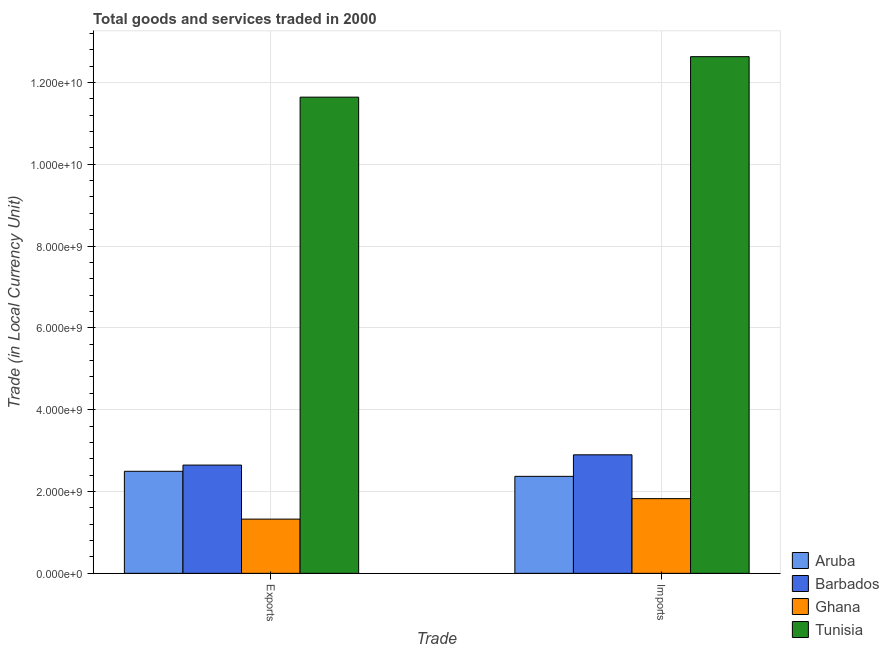How many different coloured bars are there?
Provide a succinct answer. 4. How many groups of bars are there?
Give a very brief answer. 2. Are the number of bars on each tick of the X-axis equal?
Offer a terse response. Yes. How many bars are there on the 2nd tick from the left?
Offer a very short reply. 4. How many bars are there on the 1st tick from the right?
Make the answer very short. 4. What is the label of the 1st group of bars from the left?
Your response must be concise. Exports. What is the imports of goods and services in Tunisia?
Give a very brief answer. 1.26e+1. Across all countries, what is the maximum export of goods and services?
Offer a very short reply. 1.16e+1. Across all countries, what is the minimum imports of goods and services?
Ensure brevity in your answer.  1.83e+09. In which country was the export of goods and services maximum?
Provide a short and direct response. Tunisia. In which country was the imports of goods and services minimum?
Ensure brevity in your answer.  Ghana. What is the total export of goods and services in the graph?
Your answer should be compact. 1.81e+1. What is the difference between the export of goods and services in Tunisia and that in Ghana?
Your answer should be very brief. 1.03e+1. What is the difference between the imports of goods and services in Ghana and the export of goods and services in Barbados?
Ensure brevity in your answer.  -8.20e+08. What is the average imports of goods and services per country?
Give a very brief answer. 4.93e+09. What is the difference between the export of goods and services and imports of goods and services in Ghana?
Your response must be concise. -5.01e+08. In how many countries, is the imports of goods and services greater than 12800000000 LCU?
Your response must be concise. 0. What is the ratio of the export of goods and services in Ghana to that in Tunisia?
Give a very brief answer. 0.11. What does the 3rd bar from the left in Exports represents?
Your response must be concise. Ghana. What does the 3rd bar from the right in Exports represents?
Keep it short and to the point. Barbados. What is the difference between two consecutive major ticks on the Y-axis?
Keep it short and to the point. 2.00e+09. Are the values on the major ticks of Y-axis written in scientific E-notation?
Your answer should be very brief. Yes. Does the graph contain grids?
Make the answer very short. Yes. How are the legend labels stacked?
Ensure brevity in your answer.  Vertical. What is the title of the graph?
Offer a very short reply. Total goods and services traded in 2000. Does "Belgium" appear as one of the legend labels in the graph?
Offer a terse response. No. What is the label or title of the X-axis?
Offer a very short reply. Trade. What is the label or title of the Y-axis?
Make the answer very short. Trade (in Local Currency Unit). What is the Trade (in Local Currency Unit) in Aruba in Exports?
Your response must be concise. 2.49e+09. What is the Trade (in Local Currency Unit) of Barbados in Exports?
Your answer should be compact. 2.65e+09. What is the Trade (in Local Currency Unit) of Ghana in Exports?
Your response must be concise. 1.33e+09. What is the Trade (in Local Currency Unit) in Tunisia in Exports?
Provide a short and direct response. 1.16e+1. What is the Trade (in Local Currency Unit) of Aruba in Imports?
Ensure brevity in your answer.  2.37e+09. What is the Trade (in Local Currency Unit) of Barbados in Imports?
Offer a terse response. 2.90e+09. What is the Trade (in Local Currency Unit) of Ghana in Imports?
Provide a succinct answer. 1.83e+09. What is the Trade (in Local Currency Unit) in Tunisia in Imports?
Provide a short and direct response. 1.26e+1. Across all Trade, what is the maximum Trade (in Local Currency Unit) of Aruba?
Provide a short and direct response. 2.49e+09. Across all Trade, what is the maximum Trade (in Local Currency Unit) of Barbados?
Provide a succinct answer. 2.90e+09. Across all Trade, what is the maximum Trade (in Local Currency Unit) in Ghana?
Offer a terse response. 1.83e+09. Across all Trade, what is the maximum Trade (in Local Currency Unit) of Tunisia?
Make the answer very short. 1.26e+1. Across all Trade, what is the minimum Trade (in Local Currency Unit) of Aruba?
Your answer should be compact. 2.37e+09. Across all Trade, what is the minimum Trade (in Local Currency Unit) of Barbados?
Ensure brevity in your answer.  2.65e+09. Across all Trade, what is the minimum Trade (in Local Currency Unit) in Ghana?
Ensure brevity in your answer.  1.33e+09. Across all Trade, what is the minimum Trade (in Local Currency Unit) of Tunisia?
Your response must be concise. 1.16e+1. What is the total Trade (in Local Currency Unit) of Aruba in the graph?
Ensure brevity in your answer.  4.86e+09. What is the total Trade (in Local Currency Unit) of Barbados in the graph?
Your answer should be very brief. 5.54e+09. What is the total Trade (in Local Currency Unit) in Ghana in the graph?
Give a very brief answer. 3.15e+09. What is the total Trade (in Local Currency Unit) of Tunisia in the graph?
Your answer should be very brief. 2.43e+1. What is the difference between the Trade (in Local Currency Unit) of Aruba in Exports and that in Imports?
Your response must be concise. 1.24e+08. What is the difference between the Trade (in Local Currency Unit) in Barbados in Exports and that in Imports?
Keep it short and to the point. -2.51e+08. What is the difference between the Trade (in Local Currency Unit) in Ghana in Exports and that in Imports?
Your answer should be very brief. -5.01e+08. What is the difference between the Trade (in Local Currency Unit) of Tunisia in Exports and that in Imports?
Your answer should be compact. -9.90e+08. What is the difference between the Trade (in Local Currency Unit) in Aruba in Exports and the Trade (in Local Currency Unit) in Barbados in Imports?
Your response must be concise. -4.02e+08. What is the difference between the Trade (in Local Currency Unit) in Aruba in Exports and the Trade (in Local Currency Unit) in Ghana in Imports?
Provide a short and direct response. 6.69e+08. What is the difference between the Trade (in Local Currency Unit) in Aruba in Exports and the Trade (in Local Currency Unit) in Tunisia in Imports?
Offer a terse response. -1.01e+1. What is the difference between the Trade (in Local Currency Unit) in Barbados in Exports and the Trade (in Local Currency Unit) in Ghana in Imports?
Your answer should be compact. 8.20e+08. What is the difference between the Trade (in Local Currency Unit) of Barbados in Exports and the Trade (in Local Currency Unit) of Tunisia in Imports?
Offer a terse response. -9.98e+09. What is the difference between the Trade (in Local Currency Unit) of Ghana in Exports and the Trade (in Local Currency Unit) of Tunisia in Imports?
Offer a terse response. -1.13e+1. What is the average Trade (in Local Currency Unit) in Aruba per Trade?
Ensure brevity in your answer.  2.43e+09. What is the average Trade (in Local Currency Unit) in Barbados per Trade?
Offer a very short reply. 2.77e+09. What is the average Trade (in Local Currency Unit) of Ghana per Trade?
Your answer should be compact. 1.58e+09. What is the average Trade (in Local Currency Unit) in Tunisia per Trade?
Offer a very short reply. 1.21e+1. What is the difference between the Trade (in Local Currency Unit) of Aruba and Trade (in Local Currency Unit) of Barbados in Exports?
Provide a succinct answer. -1.51e+08. What is the difference between the Trade (in Local Currency Unit) of Aruba and Trade (in Local Currency Unit) of Ghana in Exports?
Offer a terse response. 1.17e+09. What is the difference between the Trade (in Local Currency Unit) in Aruba and Trade (in Local Currency Unit) in Tunisia in Exports?
Your answer should be very brief. -9.15e+09. What is the difference between the Trade (in Local Currency Unit) of Barbados and Trade (in Local Currency Unit) of Ghana in Exports?
Provide a short and direct response. 1.32e+09. What is the difference between the Trade (in Local Currency Unit) of Barbados and Trade (in Local Currency Unit) of Tunisia in Exports?
Offer a terse response. -8.99e+09. What is the difference between the Trade (in Local Currency Unit) of Ghana and Trade (in Local Currency Unit) of Tunisia in Exports?
Make the answer very short. -1.03e+1. What is the difference between the Trade (in Local Currency Unit) in Aruba and Trade (in Local Currency Unit) in Barbados in Imports?
Keep it short and to the point. -5.27e+08. What is the difference between the Trade (in Local Currency Unit) in Aruba and Trade (in Local Currency Unit) in Ghana in Imports?
Offer a very short reply. 5.45e+08. What is the difference between the Trade (in Local Currency Unit) of Aruba and Trade (in Local Currency Unit) of Tunisia in Imports?
Make the answer very short. -1.03e+1. What is the difference between the Trade (in Local Currency Unit) in Barbados and Trade (in Local Currency Unit) in Ghana in Imports?
Offer a terse response. 1.07e+09. What is the difference between the Trade (in Local Currency Unit) in Barbados and Trade (in Local Currency Unit) in Tunisia in Imports?
Ensure brevity in your answer.  -9.73e+09. What is the difference between the Trade (in Local Currency Unit) of Ghana and Trade (in Local Currency Unit) of Tunisia in Imports?
Keep it short and to the point. -1.08e+1. What is the ratio of the Trade (in Local Currency Unit) of Aruba in Exports to that in Imports?
Your answer should be compact. 1.05. What is the ratio of the Trade (in Local Currency Unit) of Barbados in Exports to that in Imports?
Provide a succinct answer. 0.91. What is the ratio of the Trade (in Local Currency Unit) of Ghana in Exports to that in Imports?
Offer a terse response. 0.73. What is the ratio of the Trade (in Local Currency Unit) of Tunisia in Exports to that in Imports?
Your response must be concise. 0.92. What is the difference between the highest and the second highest Trade (in Local Currency Unit) of Aruba?
Make the answer very short. 1.24e+08. What is the difference between the highest and the second highest Trade (in Local Currency Unit) in Barbados?
Provide a succinct answer. 2.51e+08. What is the difference between the highest and the second highest Trade (in Local Currency Unit) in Ghana?
Your answer should be very brief. 5.01e+08. What is the difference between the highest and the second highest Trade (in Local Currency Unit) in Tunisia?
Provide a short and direct response. 9.90e+08. What is the difference between the highest and the lowest Trade (in Local Currency Unit) of Aruba?
Your response must be concise. 1.24e+08. What is the difference between the highest and the lowest Trade (in Local Currency Unit) of Barbados?
Give a very brief answer. 2.51e+08. What is the difference between the highest and the lowest Trade (in Local Currency Unit) of Ghana?
Make the answer very short. 5.01e+08. What is the difference between the highest and the lowest Trade (in Local Currency Unit) in Tunisia?
Provide a succinct answer. 9.90e+08. 